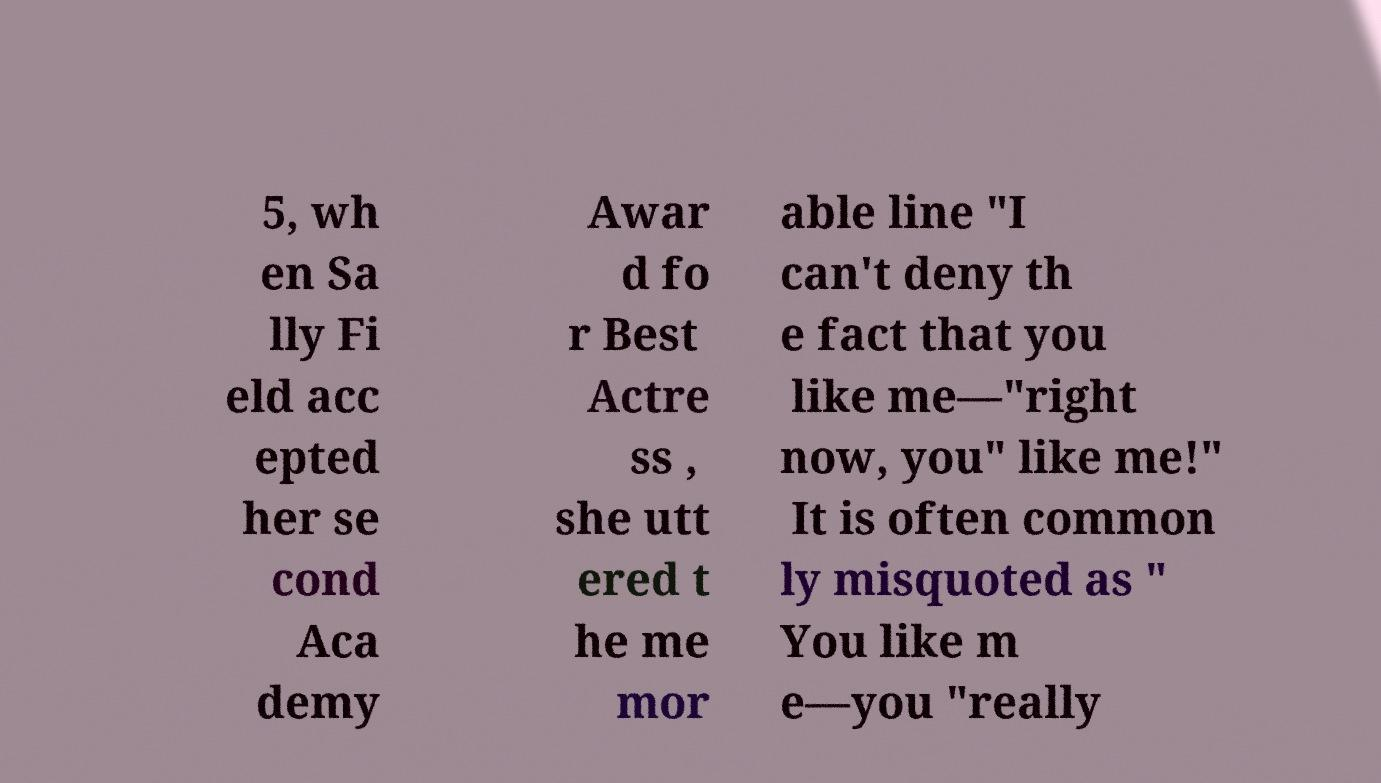Can you accurately transcribe the text from the provided image for me? 5, wh en Sa lly Fi eld acc epted her se cond Aca demy Awar d fo r Best Actre ss , she utt ered t he me mor able line "I can't deny th e fact that you like me—"right now, you" like me!" It is often common ly misquoted as " You like m e—you "really 